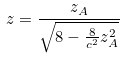Convert formula to latex. <formula><loc_0><loc_0><loc_500><loc_500>z = \frac { z _ { A } } { \sqrt { 8 - \frac { 8 } { c ^ { 2 } } z _ { A } ^ { 2 } } }</formula> 